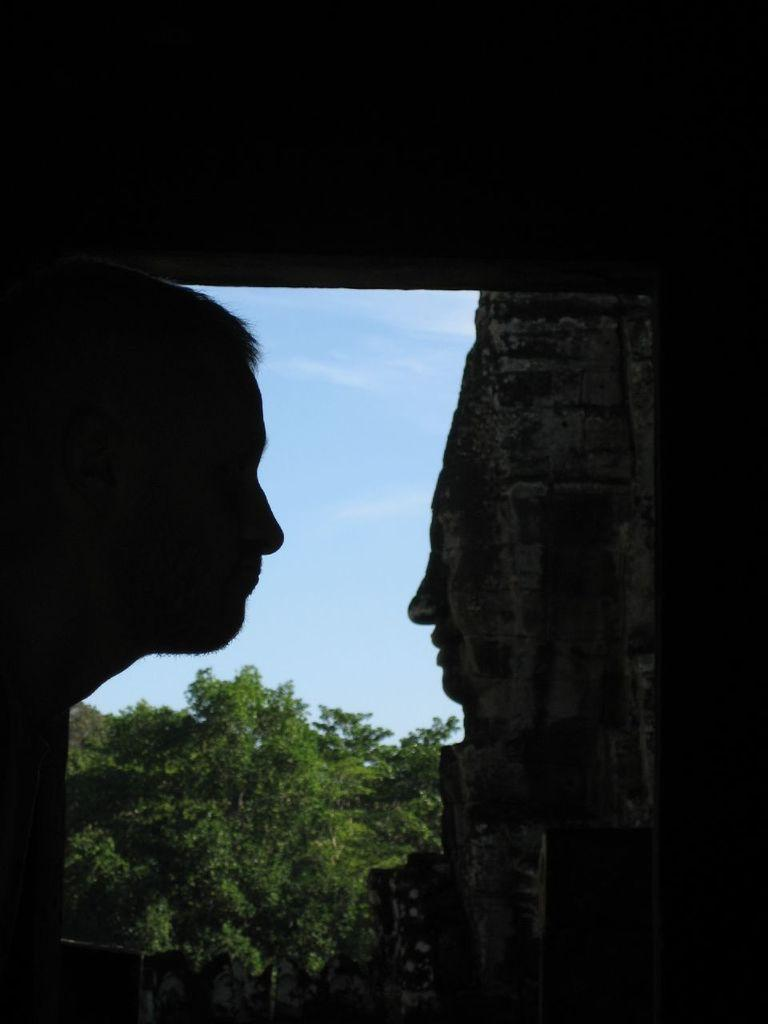What is located on the right side of the image? There is a person's head and a stone carving on the right side of the image. What type of vegetation can be seen in the background of the image? There are trees in the background of the image. What is visible in the background of the image besides the trees? The sky is visible in the background of the image. What type of quince is being held by the person in the image? There is no person holding a quince in the image; it only features a person's head and a stone carving. Can you tell me how many parents are visible in the image? There are no parents visible in the image. 